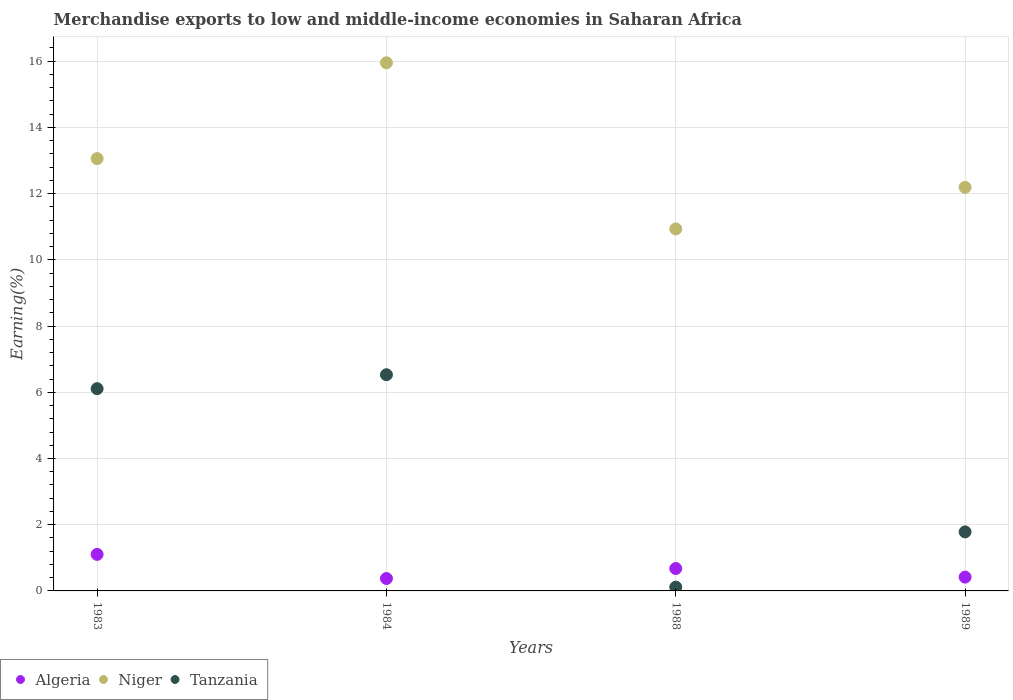Is the number of dotlines equal to the number of legend labels?
Provide a succinct answer. Yes. What is the percentage of amount earned from merchandise exports in Niger in 1984?
Provide a succinct answer. 15.95. Across all years, what is the maximum percentage of amount earned from merchandise exports in Niger?
Keep it short and to the point. 15.95. Across all years, what is the minimum percentage of amount earned from merchandise exports in Tanzania?
Provide a succinct answer. 0.11. What is the total percentage of amount earned from merchandise exports in Algeria in the graph?
Your answer should be compact. 2.57. What is the difference between the percentage of amount earned from merchandise exports in Tanzania in 1983 and that in 1989?
Your answer should be very brief. 4.33. What is the difference between the percentage of amount earned from merchandise exports in Algeria in 1984 and the percentage of amount earned from merchandise exports in Tanzania in 1989?
Your answer should be compact. -1.41. What is the average percentage of amount earned from merchandise exports in Tanzania per year?
Your answer should be very brief. 3.63. In the year 1983, what is the difference between the percentage of amount earned from merchandise exports in Niger and percentage of amount earned from merchandise exports in Tanzania?
Ensure brevity in your answer.  6.95. What is the ratio of the percentage of amount earned from merchandise exports in Niger in 1983 to that in 1988?
Provide a short and direct response. 1.19. Is the difference between the percentage of amount earned from merchandise exports in Niger in 1988 and 1989 greater than the difference between the percentage of amount earned from merchandise exports in Tanzania in 1988 and 1989?
Your answer should be compact. Yes. What is the difference between the highest and the second highest percentage of amount earned from merchandise exports in Niger?
Ensure brevity in your answer.  2.89. What is the difference between the highest and the lowest percentage of amount earned from merchandise exports in Tanzania?
Offer a terse response. 6.42. Is the sum of the percentage of amount earned from merchandise exports in Algeria in 1984 and 1989 greater than the maximum percentage of amount earned from merchandise exports in Niger across all years?
Ensure brevity in your answer.  No. Is the percentage of amount earned from merchandise exports in Algeria strictly less than the percentage of amount earned from merchandise exports in Niger over the years?
Provide a short and direct response. Yes. How many years are there in the graph?
Your answer should be very brief. 4. Does the graph contain any zero values?
Your answer should be compact. No. Does the graph contain grids?
Make the answer very short. Yes. Where does the legend appear in the graph?
Give a very brief answer. Bottom left. What is the title of the graph?
Make the answer very short. Merchandise exports to low and middle-income economies in Saharan Africa. Does "Vietnam" appear as one of the legend labels in the graph?
Your response must be concise. No. What is the label or title of the Y-axis?
Provide a succinct answer. Earning(%). What is the Earning(%) of Algeria in 1983?
Your response must be concise. 1.1. What is the Earning(%) of Niger in 1983?
Offer a very short reply. 13.06. What is the Earning(%) in Tanzania in 1983?
Offer a terse response. 6.11. What is the Earning(%) in Algeria in 1984?
Provide a succinct answer. 0.37. What is the Earning(%) of Niger in 1984?
Your answer should be very brief. 15.95. What is the Earning(%) in Tanzania in 1984?
Keep it short and to the point. 6.53. What is the Earning(%) of Algeria in 1988?
Give a very brief answer. 0.68. What is the Earning(%) in Niger in 1988?
Provide a short and direct response. 10.93. What is the Earning(%) in Tanzania in 1988?
Offer a terse response. 0.11. What is the Earning(%) in Algeria in 1989?
Keep it short and to the point. 0.42. What is the Earning(%) in Niger in 1989?
Ensure brevity in your answer.  12.19. What is the Earning(%) of Tanzania in 1989?
Make the answer very short. 1.78. Across all years, what is the maximum Earning(%) of Algeria?
Offer a terse response. 1.1. Across all years, what is the maximum Earning(%) in Niger?
Keep it short and to the point. 15.95. Across all years, what is the maximum Earning(%) in Tanzania?
Provide a short and direct response. 6.53. Across all years, what is the minimum Earning(%) of Algeria?
Ensure brevity in your answer.  0.37. Across all years, what is the minimum Earning(%) of Niger?
Keep it short and to the point. 10.93. Across all years, what is the minimum Earning(%) of Tanzania?
Keep it short and to the point. 0.11. What is the total Earning(%) in Algeria in the graph?
Keep it short and to the point. 2.57. What is the total Earning(%) in Niger in the graph?
Make the answer very short. 52.14. What is the total Earning(%) in Tanzania in the graph?
Offer a very short reply. 14.54. What is the difference between the Earning(%) of Algeria in 1983 and that in 1984?
Your response must be concise. 0.73. What is the difference between the Earning(%) in Niger in 1983 and that in 1984?
Make the answer very short. -2.89. What is the difference between the Earning(%) of Tanzania in 1983 and that in 1984?
Ensure brevity in your answer.  -0.42. What is the difference between the Earning(%) in Algeria in 1983 and that in 1988?
Give a very brief answer. 0.43. What is the difference between the Earning(%) in Niger in 1983 and that in 1988?
Provide a succinct answer. 2.13. What is the difference between the Earning(%) of Tanzania in 1983 and that in 1988?
Ensure brevity in your answer.  5.99. What is the difference between the Earning(%) of Algeria in 1983 and that in 1989?
Your answer should be compact. 0.69. What is the difference between the Earning(%) in Niger in 1983 and that in 1989?
Give a very brief answer. 0.87. What is the difference between the Earning(%) of Tanzania in 1983 and that in 1989?
Offer a very short reply. 4.33. What is the difference between the Earning(%) in Algeria in 1984 and that in 1988?
Provide a succinct answer. -0.3. What is the difference between the Earning(%) in Niger in 1984 and that in 1988?
Provide a succinct answer. 5.02. What is the difference between the Earning(%) in Tanzania in 1984 and that in 1988?
Keep it short and to the point. 6.42. What is the difference between the Earning(%) of Algeria in 1984 and that in 1989?
Your response must be concise. -0.04. What is the difference between the Earning(%) in Niger in 1984 and that in 1989?
Offer a very short reply. 3.76. What is the difference between the Earning(%) in Tanzania in 1984 and that in 1989?
Make the answer very short. 4.75. What is the difference between the Earning(%) of Algeria in 1988 and that in 1989?
Provide a short and direct response. 0.26. What is the difference between the Earning(%) in Niger in 1988 and that in 1989?
Offer a very short reply. -1.26. What is the difference between the Earning(%) of Tanzania in 1988 and that in 1989?
Make the answer very short. -1.67. What is the difference between the Earning(%) of Algeria in 1983 and the Earning(%) of Niger in 1984?
Your answer should be very brief. -14.85. What is the difference between the Earning(%) in Algeria in 1983 and the Earning(%) in Tanzania in 1984?
Ensure brevity in your answer.  -5.43. What is the difference between the Earning(%) in Niger in 1983 and the Earning(%) in Tanzania in 1984?
Make the answer very short. 6.53. What is the difference between the Earning(%) in Algeria in 1983 and the Earning(%) in Niger in 1988?
Provide a short and direct response. -9.83. What is the difference between the Earning(%) in Niger in 1983 and the Earning(%) in Tanzania in 1988?
Offer a very short reply. 12.95. What is the difference between the Earning(%) of Algeria in 1983 and the Earning(%) of Niger in 1989?
Provide a short and direct response. -11.09. What is the difference between the Earning(%) in Algeria in 1983 and the Earning(%) in Tanzania in 1989?
Provide a short and direct response. -0.68. What is the difference between the Earning(%) in Niger in 1983 and the Earning(%) in Tanzania in 1989?
Your answer should be very brief. 11.28. What is the difference between the Earning(%) in Algeria in 1984 and the Earning(%) in Niger in 1988?
Your answer should be very brief. -10.56. What is the difference between the Earning(%) of Algeria in 1984 and the Earning(%) of Tanzania in 1988?
Offer a terse response. 0.26. What is the difference between the Earning(%) of Niger in 1984 and the Earning(%) of Tanzania in 1988?
Your answer should be very brief. 15.84. What is the difference between the Earning(%) in Algeria in 1984 and the Earning(%) in Niger in 1989?
Your answer should be very brief. -11.82. What is the difference between the Earning(%) of Algeria in 1984 and the Earning(%) of Tanzania in 1989?
Provide a succinct answer. -1.41. What is the difference between the Earning(%) of Niger in 1984 and the Earning(%) of Tanzania in 1989?
Make the answer very short. 14.17. What is the difference between the Earning(%) of Algeria in 1988 and the Earning(%) of Niger in 1989?
Provide a short and direct response. -11.51. What is the difference between the Earning(%) in Algeria in 1988 and the Earning(%) in Tanzania in 1989?
Provide a succinct answer. -1.11. What is the difference between the Earning(%) in Niger in 1988 and the Earning(%) in Tanzania in 1989?
Offer a very short reply. 9.15. What is the average Earning(%) in Algeria per year?
Give a very brief answer. 0.64. What is the average Earning(%) in Niger per year?
Give a very brief answer. 13.03. What is the average Earning(%) of Tanzania per year?
Provide a short and direct response. 3.63. In the year 1983, what is the difference between the Earning(%) of Algeria and Earning(%) of Niger?
Make the answer very short. -11.96. In the year 1983, what is the difference between the Earning(%) of Algeria and Earning(%) of Tanzania?
Your answer should be very brief. -5.01. In the year 1983, what is the difference between the Earning(%) in Niger and Earning(%) in Tanzania?
Your answer should be very brief. 6.95. In the year 1984, what is the difference between the Earning(%) in Algeria and Earning(%) in Niger?
Your response must be concise. -15.58. In the year 1984, what is the difference between the Earning(%) in Algeria and Earning(%) in Tanzania?
Ensure brevity in your answer.  -6.16. In the year 1984, what is the difference between the Earning(%) in Niger and Earning(%) in Tanzania?
Provide a short and direct response. 9.42. In the year 1988, what is the difference between the Earning(%) of Algeria and Earning(%) of Niger?
Your response must be concise. -10.26. In the year 1988, what is the difference between the Earning(%) in Algeria and Earning(%) in Tanzania?
Ensure brevity in your answer.  0.56. In the year 1988, what is the difference between the Earning(%) in Niger and Earning(%) in Tanzania?
Your answer should be compact. 10.82. In the year 1989, what is the difference between the Earning(%) of Algeria and Earning(%) of Niger?
Ensure brevity in your answer.  -11.77. In the year 1989, what is the difference between the Earning(%) in Algeria and Earning(%) in Tanzania?
Offer a terse response. -1.37. In the year 1989, what is the difference between the Earning(%) of Niger and Earning(%) of Tanzania?
Ensure brevity in your answer.  10.41. What is the ratio of the Earning(%) in Algeria in 1983 to that in 1984?
Keep it short and to the point. 2.94. What is the ratio of the Earning(%) of Niger in 1983 to that in 1984?
Your response must be concise. 0.82. What is the ratio of the Earning(%) of Tanzania in 1983 to that in 1984?
Provide a succinct answer. 0.94. What is the ratio of the Earning(%) of Algeria in 1983 to that in 1988?
Provide a short and direct response. 1.63. What is the ratio of the Earning(%) in Niger in 1983 to that in 1988?
Your answer should be compact. 1.19. What is the ratio of the Earning(%) of Tanzania in 1983 to that in 1988?
Offer a very short reply. 53.35. What is the ratio of the Earning(%) of Algeria in 1983 to that in 1989?
Your response must be concise. 2.64. What is the ratio of the Earning(%) of Niger in 1983 to that in 1989?
Provide a short and direct response. 1.07. What is the ratio of the Earning(%) in Tanzania in 1983 to that in 1989?
Offer a terse response. 3.43. What is the ratio of the Earning(%) in Algeria in 1984 to that in 1988?
Your answer should be compact. 0.55. What is the ratio of the Earning(%) in Niger in 1984 to that in 1988?
Give a very brief answer. 1.46. What is the ratio of the Earning(%) of Tanzania in 1984 to that in 1988?
Keep it short and to the point. 57.03. What is the ratio of the Earning(%) of Algeria in 1984 to that in 1989?
Provide a short and direct response. 0.9. What is the ratio of the Earning(%) of Niger in 1984 to that in 1989?
Ensure brevity in your answer.  1.31. What is the ratio of the Earning(%) in Tanzania in 1984 to that in 1989?
Your response must be concise. 3.66. What is the ratio of the Earning(%) in Algeria in 1988 to that in 1989?
Offer a terse response. 1.62. What is the ratio of the Earning(%) of Niger in 1988 to that in 1989?
Your answer should be compact. 0.9. What is the ratio of the Earning(%) in Tanzania in 1988 to that in 1989?
Make the answer very short. 0.06. What is the difference between the highest and the second highest Earning(%) of Algeria?
Offer a terse response. 0.43. What is the difference between the highest and the second highest Earning(%) of Niger?
Your answer should be very brief. 2.89. What is the difference between the highest and the second highest Earning(%) of Tanzania?
Provide a short and direct response. 0.42. What is the difference between the highest and the lowest Earning(%) in Algeria?
Give a very brief answer. 0.73. What is the difference between the highest and the lowest Earning(%) in Niger?
Give a very brief answer. 5.02. What is the difference between the highest and the lowest Earning(%) of Tanzania?
Your response must be concise. 6.42. 